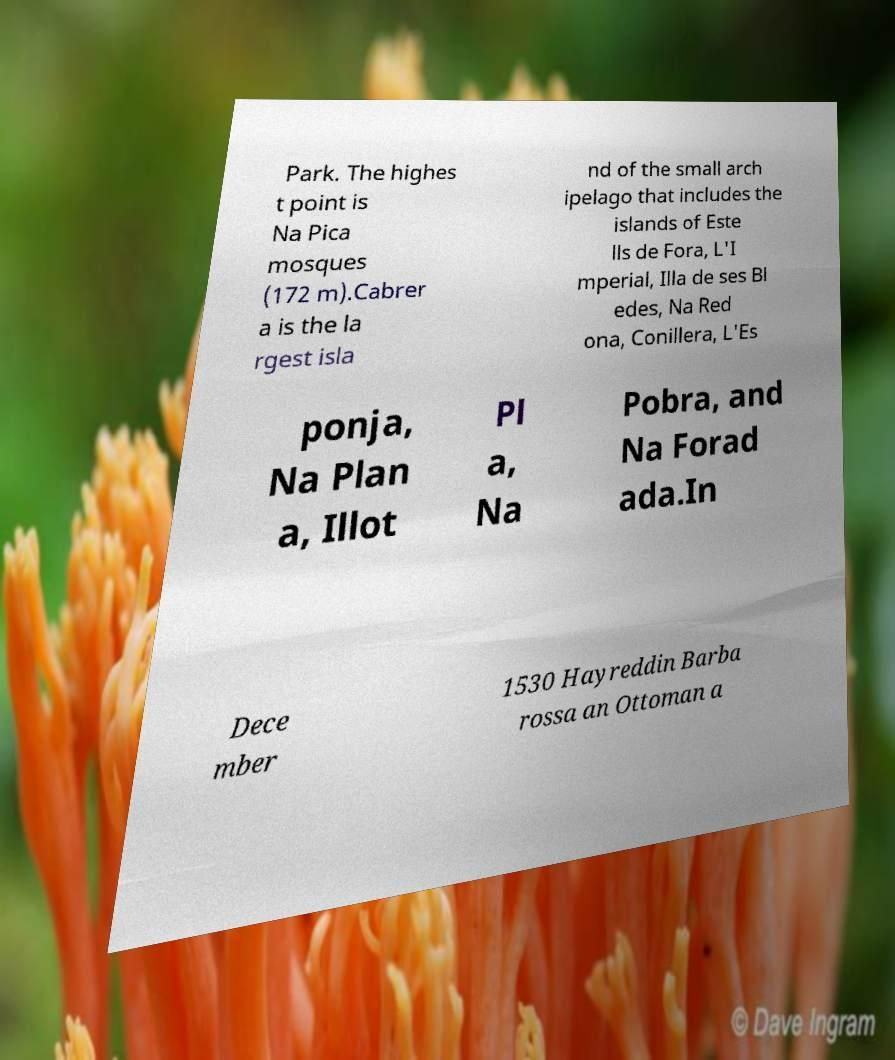For documentation purposes, I need the text within this image transcribed. Could you provide that? Park. The highes t point is Na Pica mosques (172 m).Cabrer a is the la rgest isla nd of the small arch ipelago that includes the islands of Este lls de Fora, L'I mperial, Illa de ses Bl edes, Na Red ona, Conillera, L'Es ponja, Na Plan a, Illot Pl a, Na Pobra, and Na Forad ada.In Dece mber 1530 Hayreddin Barba rossa an Ottoman a 